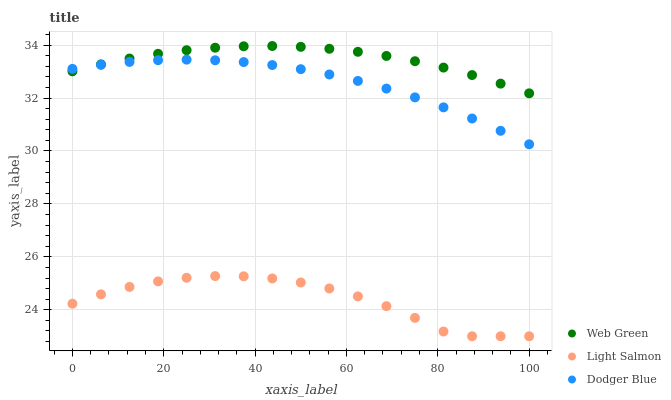Does Light Salmon have the minimum area under the curve?
Answer yes or no. Yes. Does Web Green have the maximum area under the curve?
Answer yes or no. Yes. Does Dodger Blue have the minimum area under the curve?
Answer yes or no. No. Does Dodger Blue have the maximum area under the curve?
Answer yes or no. No. Is Web Green the smoothest?
Answer yes or no. Yes. Is Light Salmon the roughest?
Answer yes or no. Yes. Is Dodger Blue the smoothest?
Answer yes or no. No. Is Dodger Blue the roughest?
Answer yes or no. No. Does Light Salmon have the lowest value?
Answer yes or no. Yes. Does Dodger Blue have the lowest value?
Answer yes or no. No. Does Web Green have the highest value?
Answer yes or no. Yes. Does Dodger Blue have the highest value?
Answer yes or no. No. Is Light Salmon less than Web Green?
Answer yes or no. Yes. Is Dodger Blue greater than Light Salmon?
Answer yes or no. Yes. Does Dodger Blue intersect Web Green?
Answer yes or no. Yes. Is Dodger Blue less than Web Green?
Answer yes or no. No. Is Dodger Blue greater than Web Green?
Answer yes or no. No. Does Light Salmon intersect Web Green?
Answer yes or no. No. 